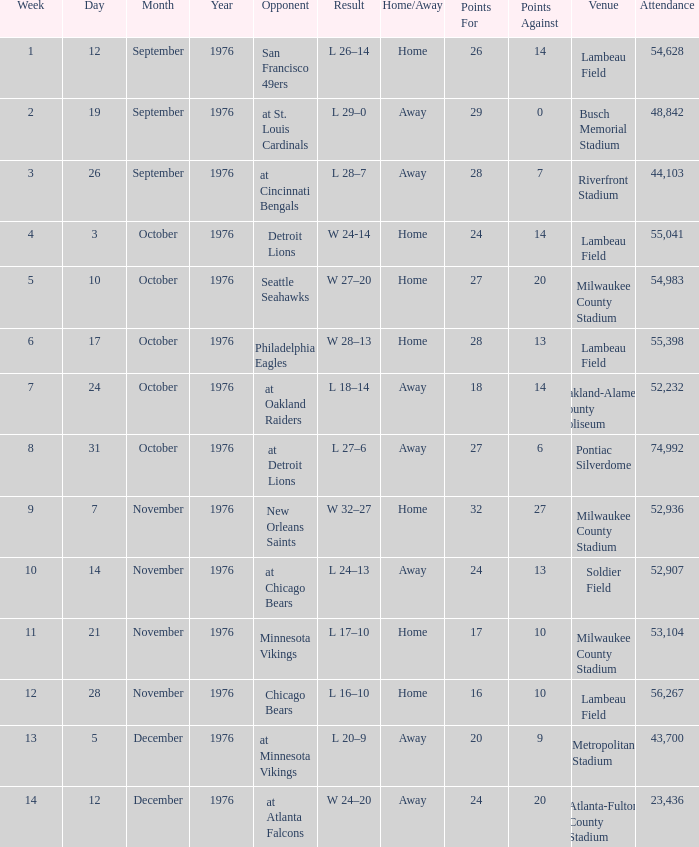In which week number did they play against the detroit lions at the earliest? 4.0. 